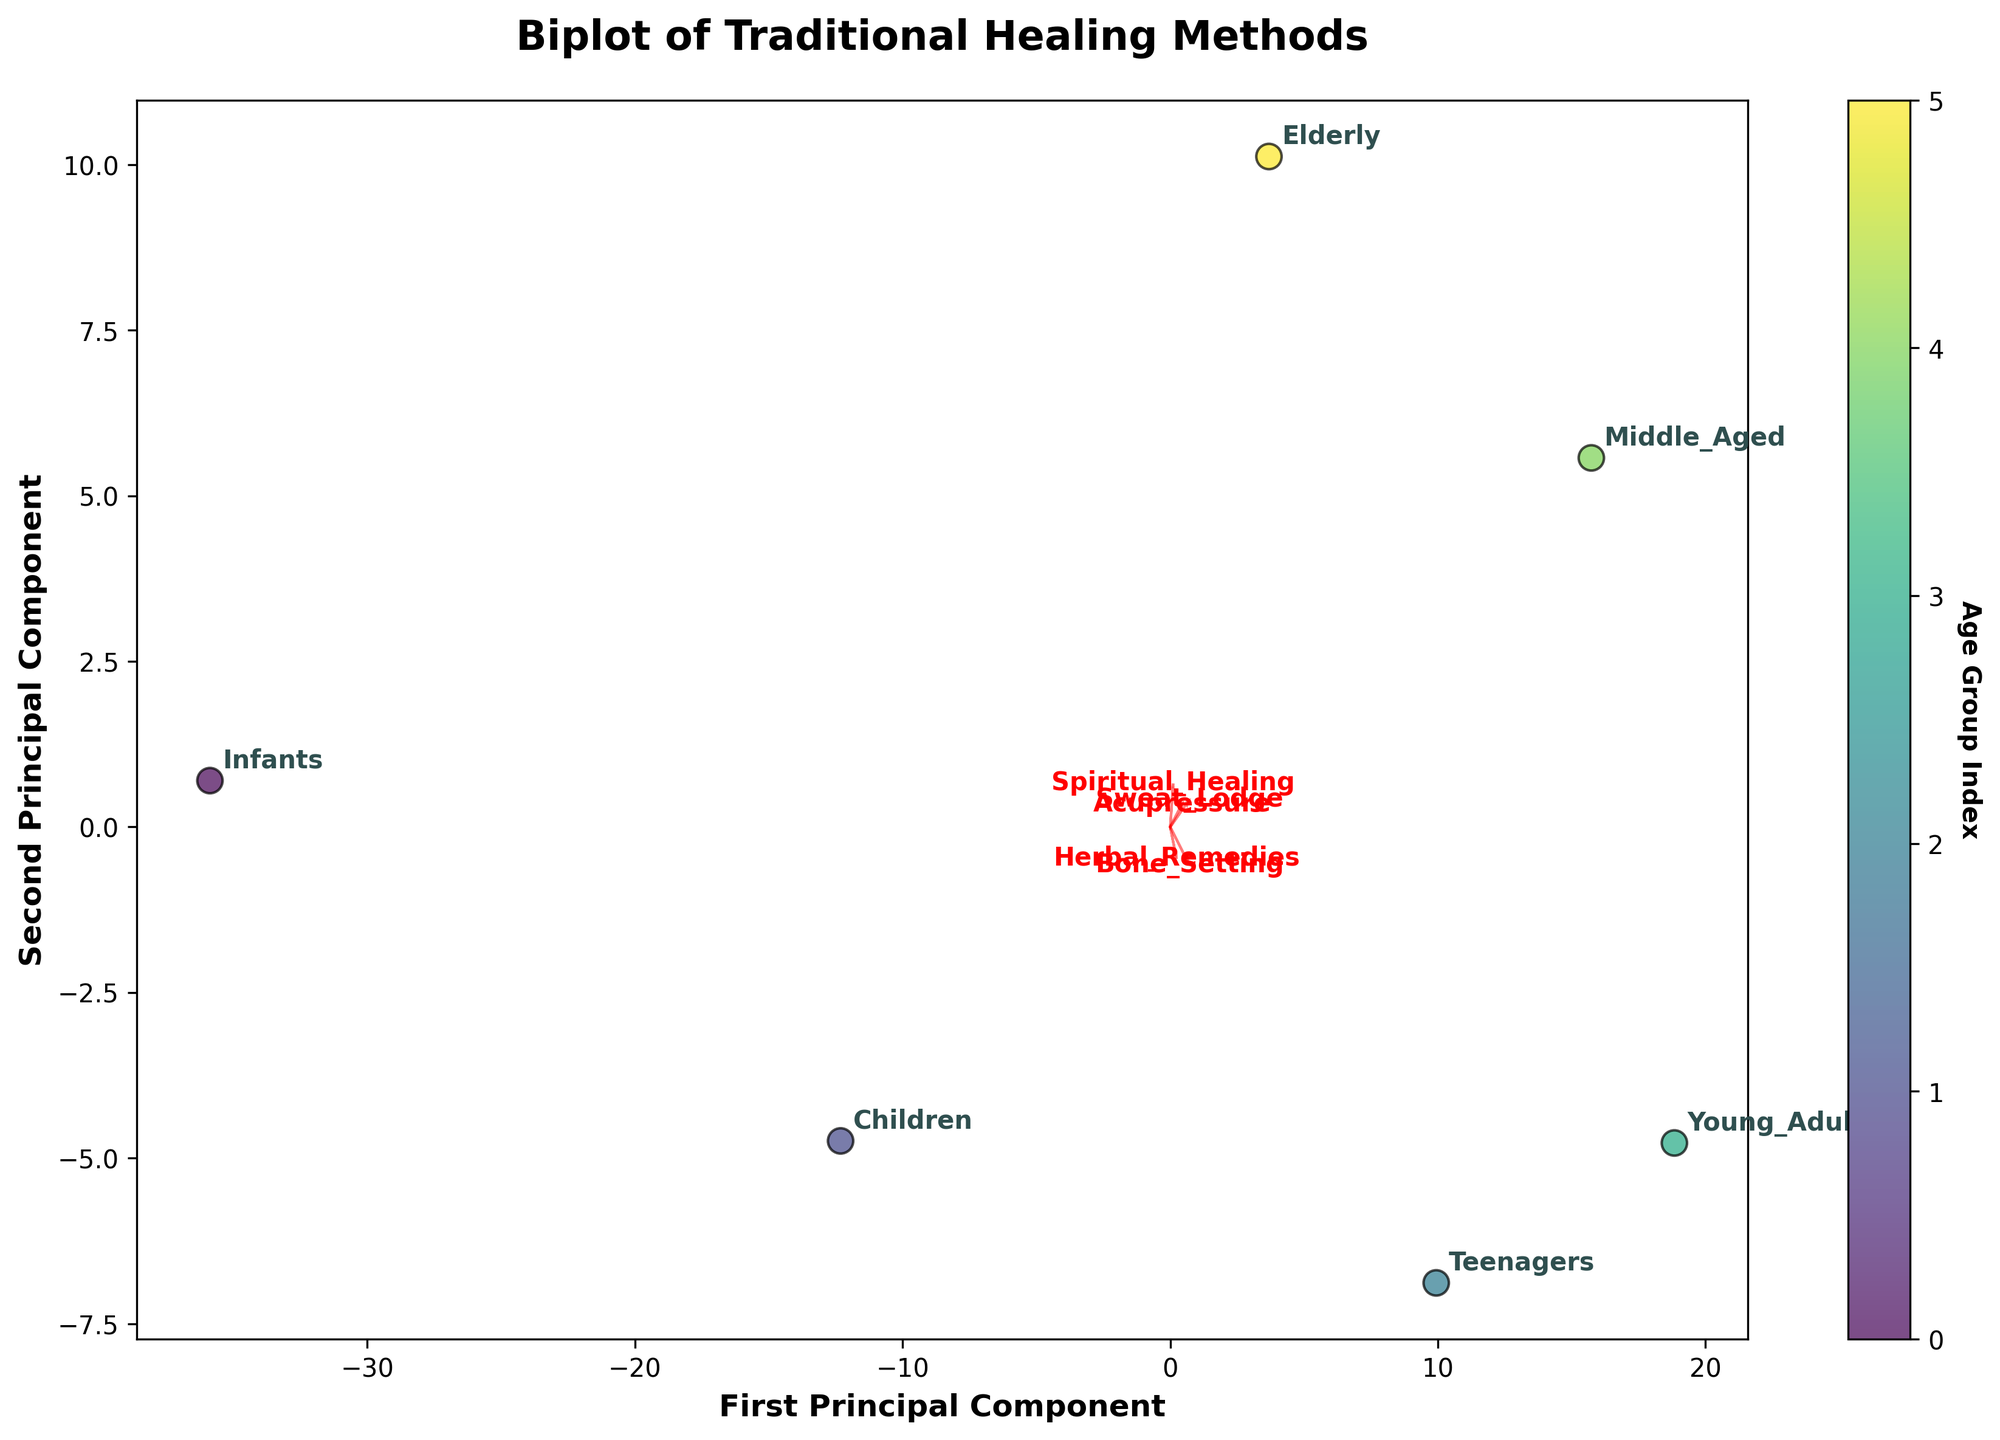what does this figure show? The figure is a biplot that shows the relationship between traditional healing methods and age groups. It includes two principal components, with data points representing different age groups and arrows indicating the feature vectors for the different traditional healing methods. The color bar on the side indicates the age group index.
Answer: A biplot of traditional healing methods across different age groups What are the axes labels and what do they represent? The x-axis is labeled 'First Principal Component', and the y-axis is labeled 'Second Principal Component'. These axes represent the first and second principal components derived from PCA, which capture the most significant variance among the healing methods data.
Answer: First Principal Component, Second Principal Component Which age group is closest to the 'Herbal_Remedies' arrow? From observing the figure, the age group 'Young Adults' appears closest to the 'Herbal_Remedies' arrow, indicating a strong relationship between young adults and the use of herbal remedies.
Answer: Young Adults How many age groups are represented in the biplot? The figure includes six annotated data points representing the different age groups: Infants, Children, Teenagers, Young Adults, Middle-Aged, and Elderly.
Answer: Six Which healing method has the longest feature vector and what does it imply? Observing the figure, the 'Bone_Setting' method has the longest feature vector. This implies that 'Bone_Setting' has the strongest influence on the principal components and explains a significant variance in the data.
Answer: Bone_Setting Do 'Teenagers' and 'Young Adults' share similar recovery rates across the healing methods? By examining the proximity of the 'Teenagers' and 'Young Adults' data points, we see they are placed relatively close together, indicating that their recovery rates are similar across various traditional healing methods.
Answer: Yes Which age group shows the highest recovery rates for 'Spiritual_Healing'? The 'Elderly' age group is closest to the 'Spiritual_Healing' arrow, suggesting that they show the highest recovery rates for spiritual healing.
Answer: Elderly Are any age groups equally distant from both principal components? None of the age groups appears to be equidistant from both principal components. Each age group's point is closer to one component than the other, indicating varying recovery rates.
Answer: No How does 'Acupressure' compare in recovery rate between 'Children' and 'Middle_Aged'? Observing the biplot, both 'Children' and 'Middle_Aged' are relatively close to the 'Acupressure' arrow. However, 'Middle_Aged' is slightly closer, indicating better recovery rates for 'Acupressure' in 'Middle_Aged' compared to 'Children'.
Answer: Middle_Aged Which age group is farthest from the 'Sweat_Lodge' arrow, and what does this imply? 'Infants' are farthest from the 'Sweat_Lodge' arrow in the biplot. This suggests that infants have the lowest recovery rates with the use of 'Sweat_Lodge'.
Answer: Infants 